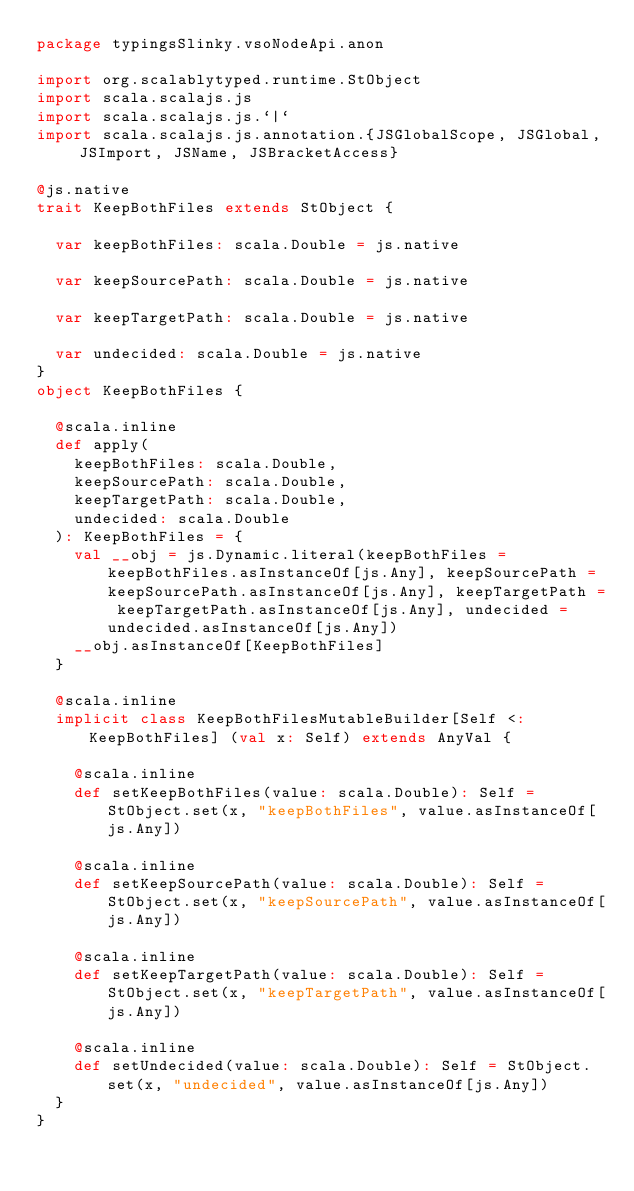Convert code to text. <code><loc_0><loc_0><loc_500><loc_500><_Scala_>package typingsSlinky.vsoNodeApi.anon

import org.scalablytyped.runtime.StObject
import scala.scalajs.js
import scala.scalajs.js.`|`
import scala.scalajs.js.annotation.{JSGlobalScope, JSGlobal, JSImport, JSName, JSBracketAccess}

@js.native
trait KeepBothFiles extends StObject {
  
  var keepBothFiles: scala.Double = js.native
  
  var keepSourcePath: scala.Double = js.native
  
  var keepTargetPath: scala.Double = js.native
  
  var undecided: scala.Double = js.native
}
object KeepBothFiles {
  
  @scala.inline
  def apply(
    keepBothFiles: scala.Double,
    keepSourcePath: scala.Double,
    keepTargetPath: scala.Double,
    undecided: scala.Double
  ): KeepBothFiles = {
    val __obj = js.Dynamic.literal(keepBothFiles = keepBothFiles.asInstanceOf[js.Any], keepSourcePath = keepSourcePath.asInstanceOf[js.Any], keepTargetPath = keepTargetPath.asInstanceOf[js.Any], undecided = undecided.asInstanceOf[js.Any])
    __obj.asInstanceOf[KeepBothFiles]
  }
  
  @scala.inline
  implicit class KeepBothFilesMutableBuilder[Self <: KeepBothFiles] (val x: Self) extends AnyVal {
    
    @scala.inline
    def setKeepBothFiles(value: scala.Double): Self = StObject.set(x, "keepBothFiles", value.asInstanceOf[js.Any])
    
    @scala.inline
    def setKeepSourcePath(value: scala.Double): Self = StObject.set(x, "keepSourcePath", value.asInstanceOf[js.Any])
    
    @scala.inline
    def setKeepTargetPath(value: scala.Double): Self = StObject.set(x, "keepTargetPath", value.asInstanceOf[js.Any])
    
    @scala.inline
    def setUndecided(value: scala.Double): Self = StObject.set(x, "undecided", value.asInstanceOf[js.Any])
  }
}
</code> 